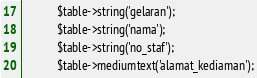<code> <loc_0><loc_0><loc_500><loc_500><_PHP_>        	$table->string('gelaran');
        	$table->string('nama');
        	$table->string('no_staf');
        	$table->mediumtext('alamat_kediaman');</code> 